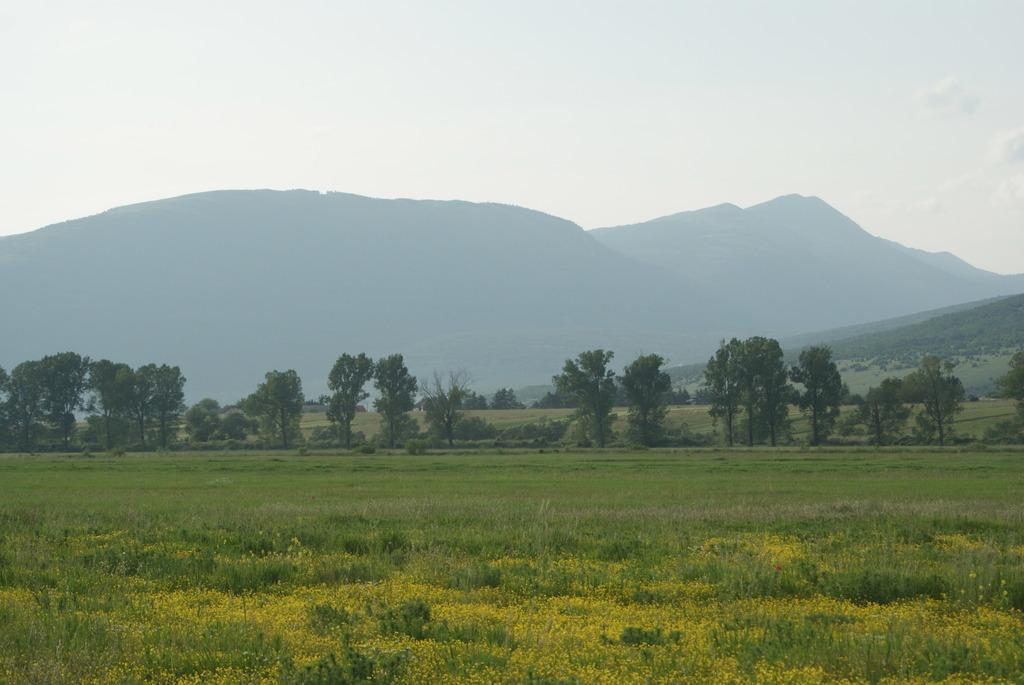What type of vegetation is present on the ground in the image? There is grass on the ground in the image. What can be seen in the background of the image? There are trees, mountains, and the sky visible in the background of the image. How much debt is the grass in the image currently in? The grass in the image does not have any debt, as it is a natural element and not a sentient being capable of incurring debt. 